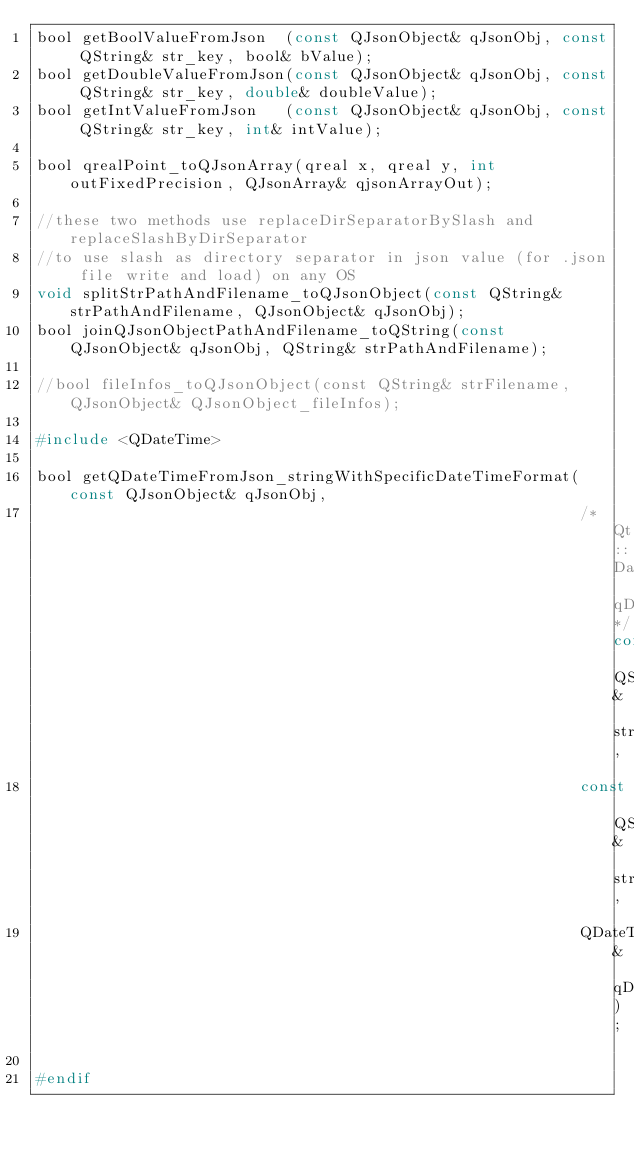Convert code to text. <code><loc_0><loc_0><loc_500><loc_500><_C_>bool getBoolValueFromJson  (const QJsonObject& qJsonObj, const QString& str_key, bool& bValue);
bool getDoubleValueFromJson(const QJsonObject& qJsonObj, const QString& str_key, double& doubleValue);
bool getIntValueFromJson   (const QJsonObject& qJsonObj, const QString& str_key, int& intValue);

bool qrealPoint_toQJsonArray(qreal x, qreal y, int outFixedPrecision, QJsonArray& qjsonArrayOut);

//these two methods use replaceDirSeparatorBySlash and replaceSlashByDirSeparator
//to use slash as directory separator in json value (for .json file write and load) on any OS
void splitStrPathAndFilename_toQJsonObject(const QString& strPathAndFilename, QJsonObject& qJsonObj);
bool joinQJsonObjectPathAndFilename_toQString(const QJsonObject& qJsonObj, QString& strPathAndFilename);

//bool fileInfos_toQJsonObject(const QString& strFilename, QJsonObject& QJsonObject_fileInfos);

#include <QDateTime>

bool getQDateTimeFromJson_stringWithSpecificDateTimeFormat(const QJsonObject& qJsonObj,
                                                           /*Qt::DateFormat qDateformat*/const QString& strDateTimeFormat,
                                                           const QString& str_key,
                                                           QDateTime& qDateTimeFromQjsonObj);

#endif

</code> 